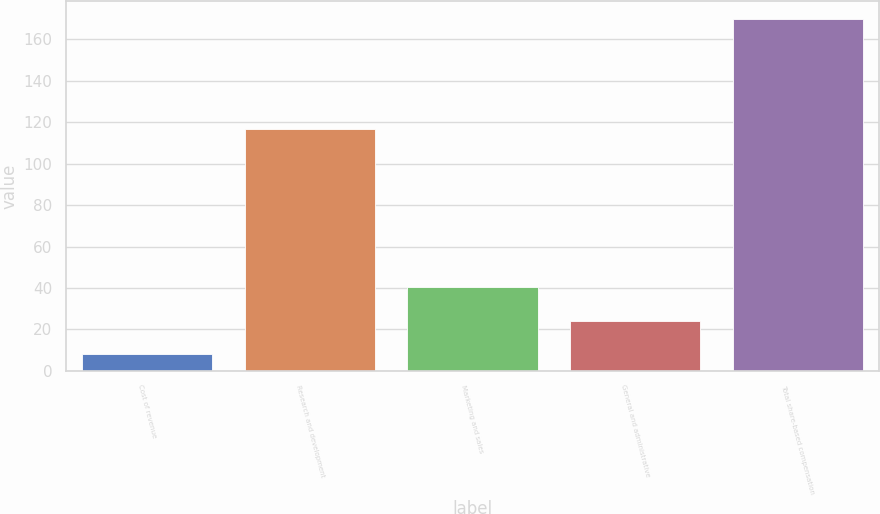Convert chart. <chart><loc_0><loc_0><loc_500><loc_500><bar_chart><fcel>Cost of revenue<fcel>Research and development<fcel>Marketing and sales<fcel>General and administrative<fcel>Total share-based compensation<nl><fcel>8<fcel>117<fcel>40.4<fcel>24.2<fcel>170<nl></chart> 